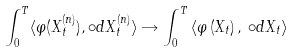<formula> <loc_0><loc_0><loc_500><loc_500>\int _ { 0 } ^ { T } \langle \varphi ( X _ { t } ^ { \left ( n \right ) } ) , \circ d X _ { t } ^ { \left ( n \right ) } \rangle \rightarrow \int _ { 0 } ^ { T } \left \langle \varphi \left ( X _ { t } \right ) , \, \circ d X _ { t } \right \rangle</formula> 